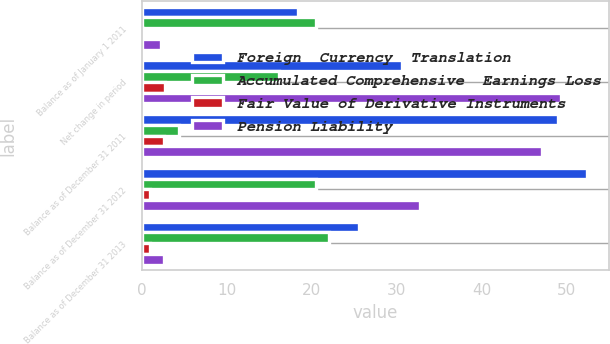Convert chart to OTSL. <chart><loc_0><loc_0><loc_500><loc_500><stacked_bar_chart><ecel><fcel>Balance as of January 1 2011<fcel>Net change in period<fcel>Balance as of December 31 2011<fcel>Balance as of December 31 2012<fcel>Balance as of December 31 2013<nl><fcel>Foreign  Currency  Translation<fcel>18.4<fcel>30.6<fcel>49<fcel>52.4<fcel>25.6<nl><fcel>Accumulated Comprehensive  Earnings Loss<fcel>20.5<fcel>16.1<fcel>4.4<fcel>20.5<fcel>22.1<nl><fcel>Fair Value of Derivative Instruments<fcel>0.1<fcel>2.7<fcel>2.6<fcel>0.9<fcel>0.9<nl><fcel>Pension Liability<fcel>2.2<fcel>49.4<fcel>47.2<fcel>32.8<fcel>2.6<nl></chart> 